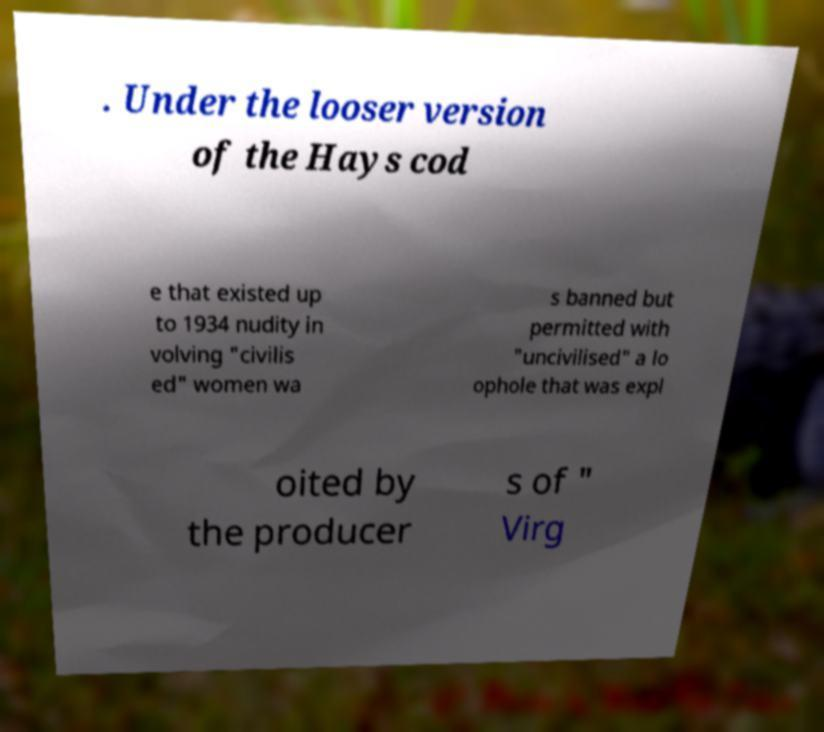Could you assist in decoding the text presented in this image and type it out clearly? . Under the looser version of the Hays cod e that existed up to 1934 nudity in volving "civilis ed" women wa s banned but permitted with "uncivilised" a lo ophole that was expl oited by the producer s of " Virg 